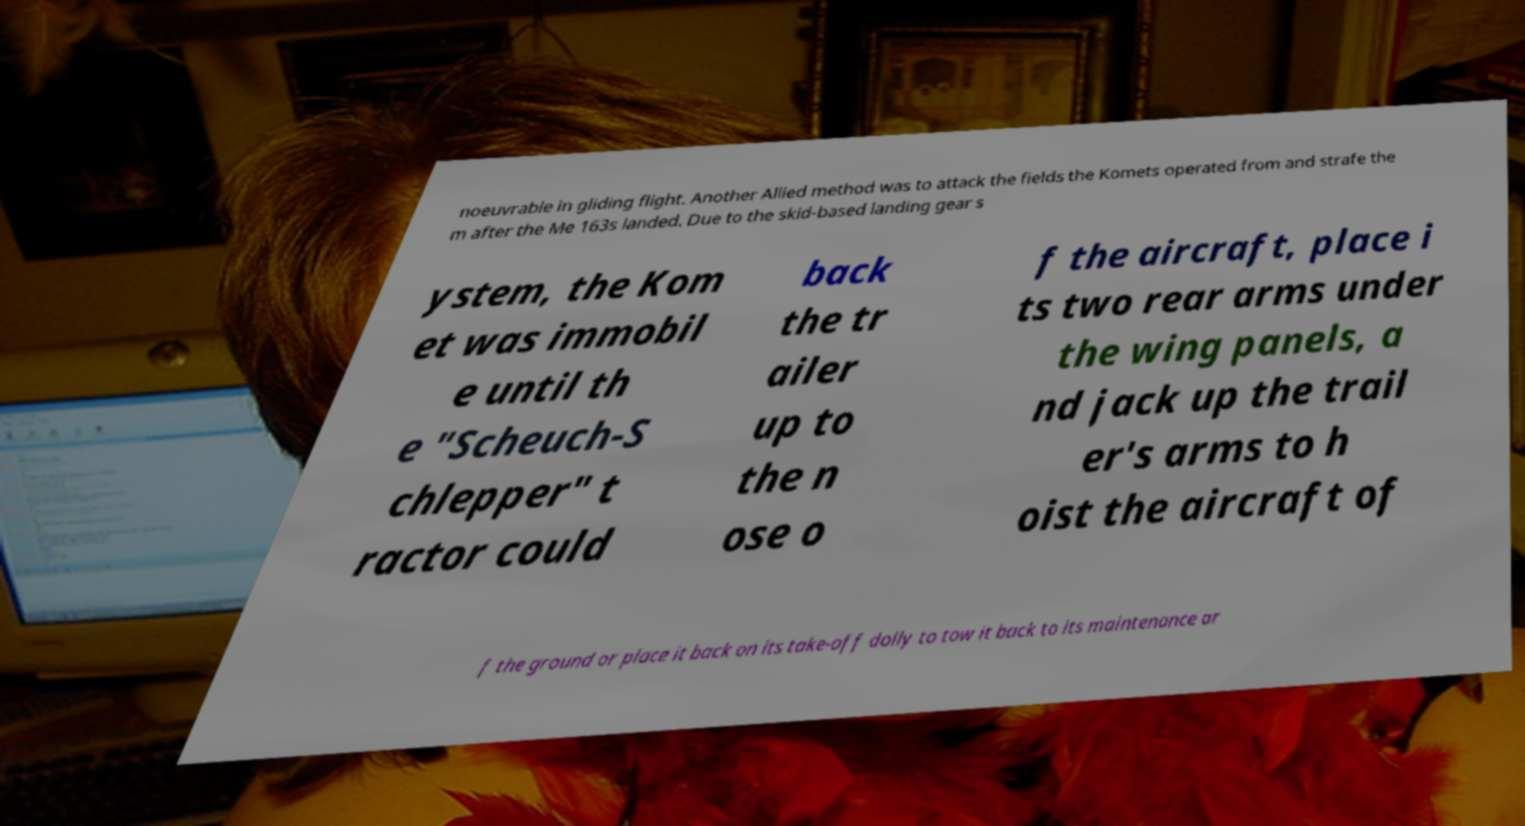Could you assist in decoding the text presented in this image and type it out clearly? noeuvrable in gliding flight. Another Allied method was to attack the fields the Komets operated from and strafe the m after the Me 163s landed. Due to the skid-based landing gear s ystem, the Kom et was immobil e until th e "Scheuch-S chlepper" t ractor could back the tr ailer up to the n ose o f the aircraft, place i ts two rear arms under the wing panels, a nd jack up the trail er's arms to h oist the aircraft of f the ground or place it back on its take-off dolly to tow it back to its maintenance ar 